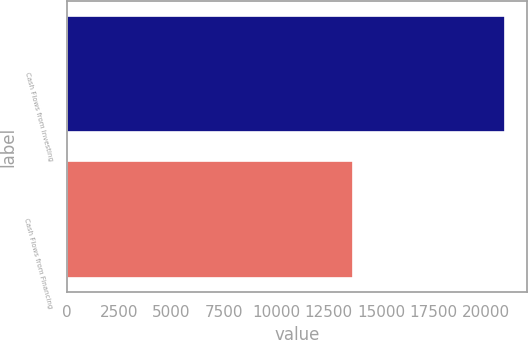Convert chart to OTSL. <chart><loc_0><loc_0><loc_500><loc_500><bar_chart><fcel>Cash Flows from Investing<fcel>Cash Flows from Financing<nl><fcel>20915<fcel>13640<nl></chart> 